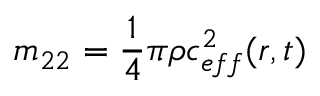Convert formula to latex. <formula><loc_0><loc_0><loc_500><loc_500>m _ { 2 2 } = \frac { 1 } { 4 } \pi \rho c _ { e f f } ^ { 2 } ( r , t )</formula> 